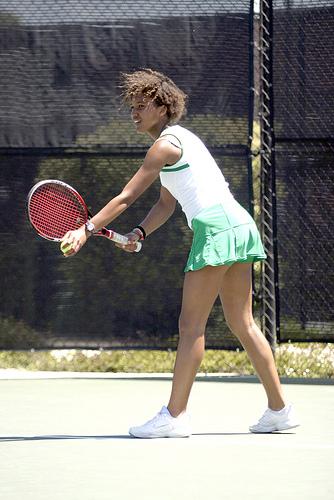Is the lady serving?
Concise answer only. Yes. What sport is being played?
Concise answer only. Tennis. Is the athlete left or right handed?
Quick response, please. Right. 